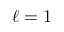<formula> <loc_0><loc_0><loc_500><loc_500>\ell = 1</formula> 